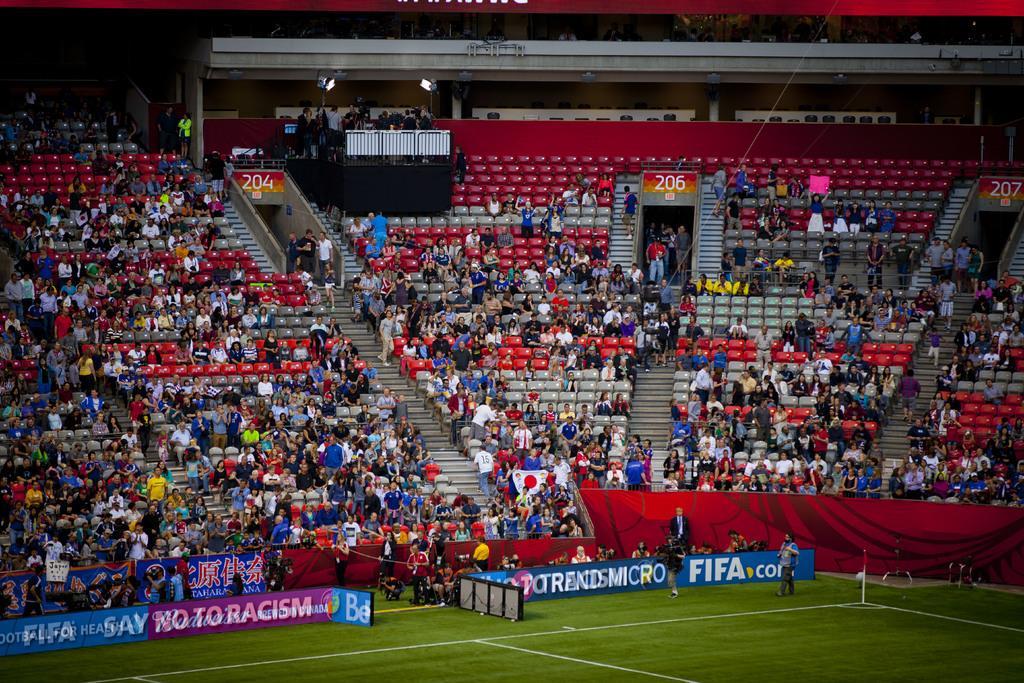How would you summarize this image in a sentence or two? In this picture I can see a stadium, there are group of people sitting on the chairs, there are group of people standing, there are boards, banners, stairs and lights. 